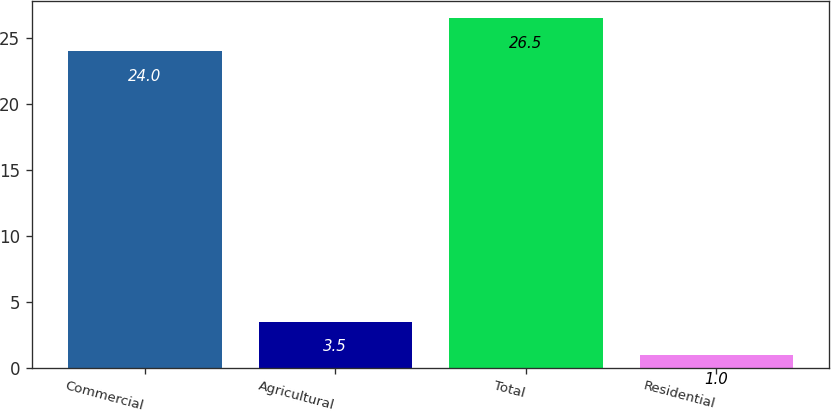<chart> <loc_0><loc_0><loc_500><loc_500><bar_chart><fcel>Commercial<fcel>Agricultural<fcel>Total<fcel>Residential<nl><fcel>24<fcel>3.5<fcel>26.5<fcel>1<nl></chart> 